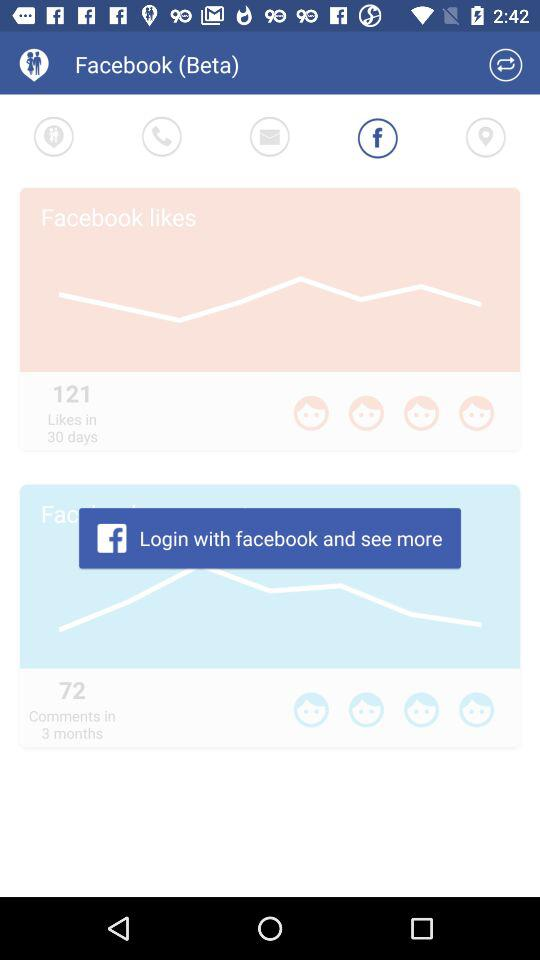How many comments in 3 months? There are 72 comments. 